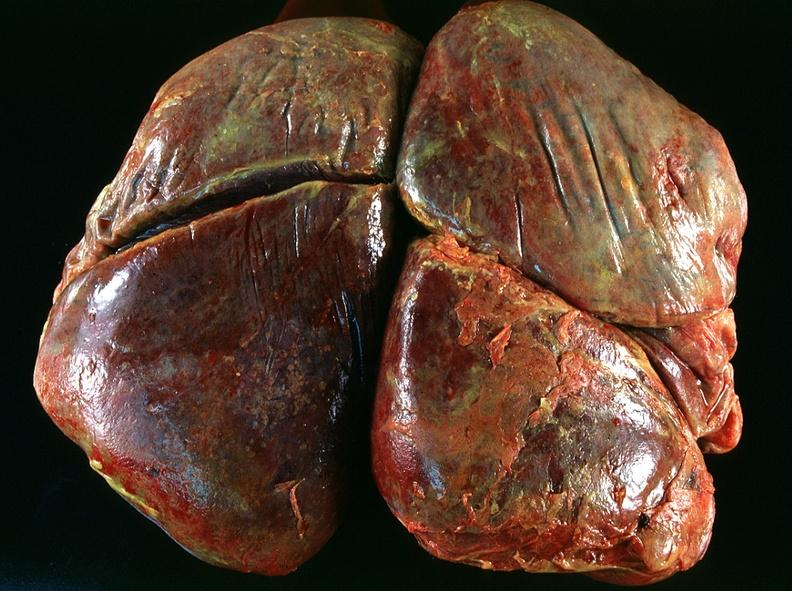does this image show lung, emphysema and pneumonia, alpha-1 antitrypsin deficiency?
Answer the question using a single word or phrase. Yes 